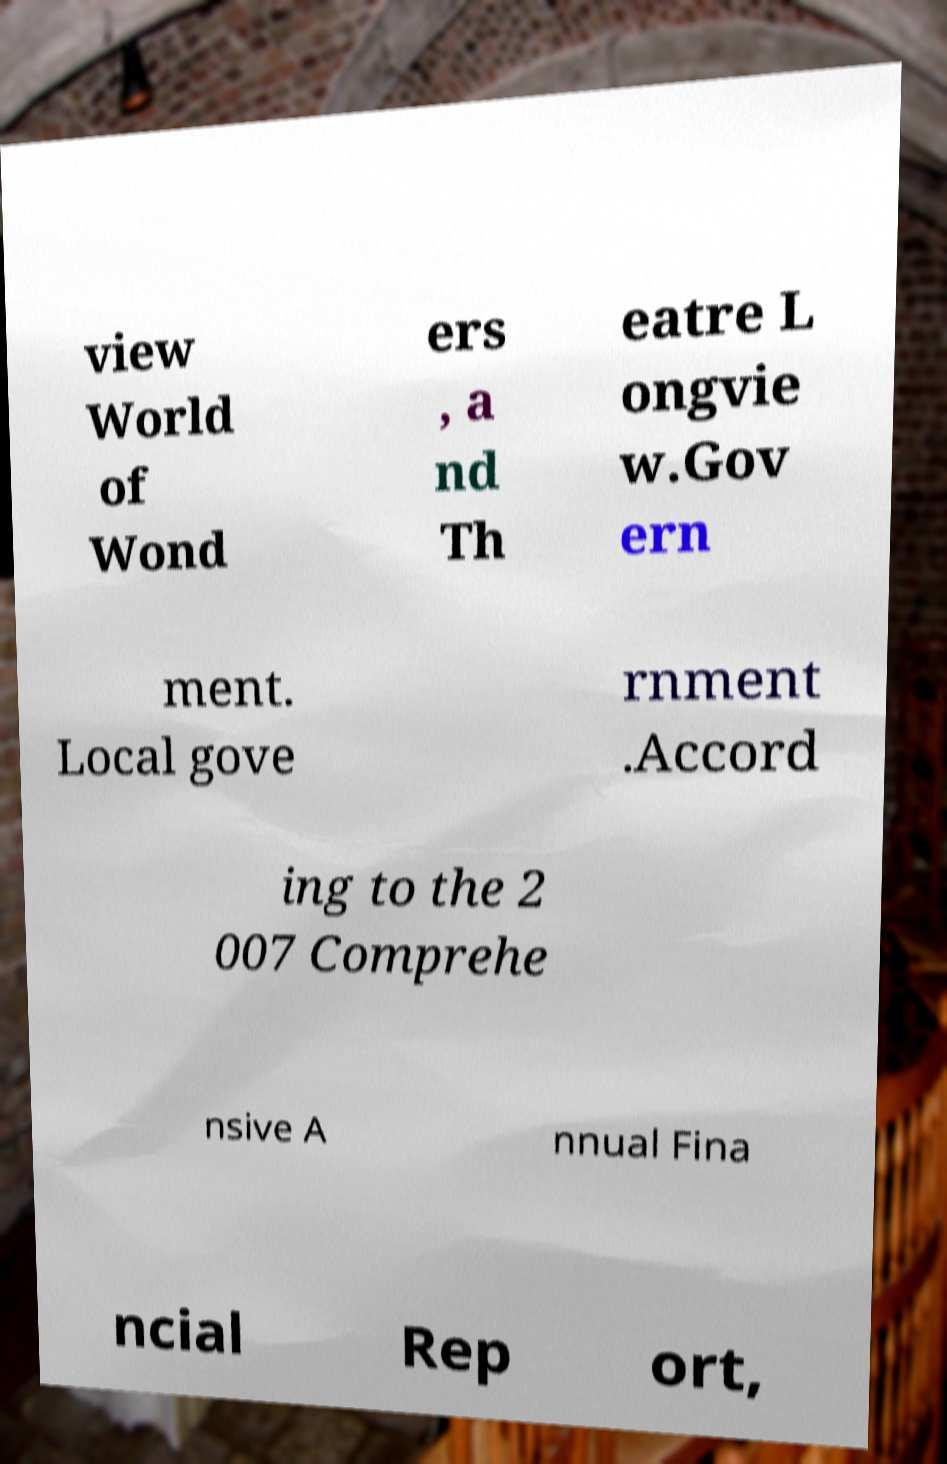Can you read and provide the text displayed in the image?This photo seems to have some interesting text. Can you extract and type it out for me? view World of Wond ers , a nd Th eatre L ongvie w.Gov ern ment. Local gove rnment .Accord ing to the 2 007 Comprehe nsive A nnual Fina ncial Rep ort, 